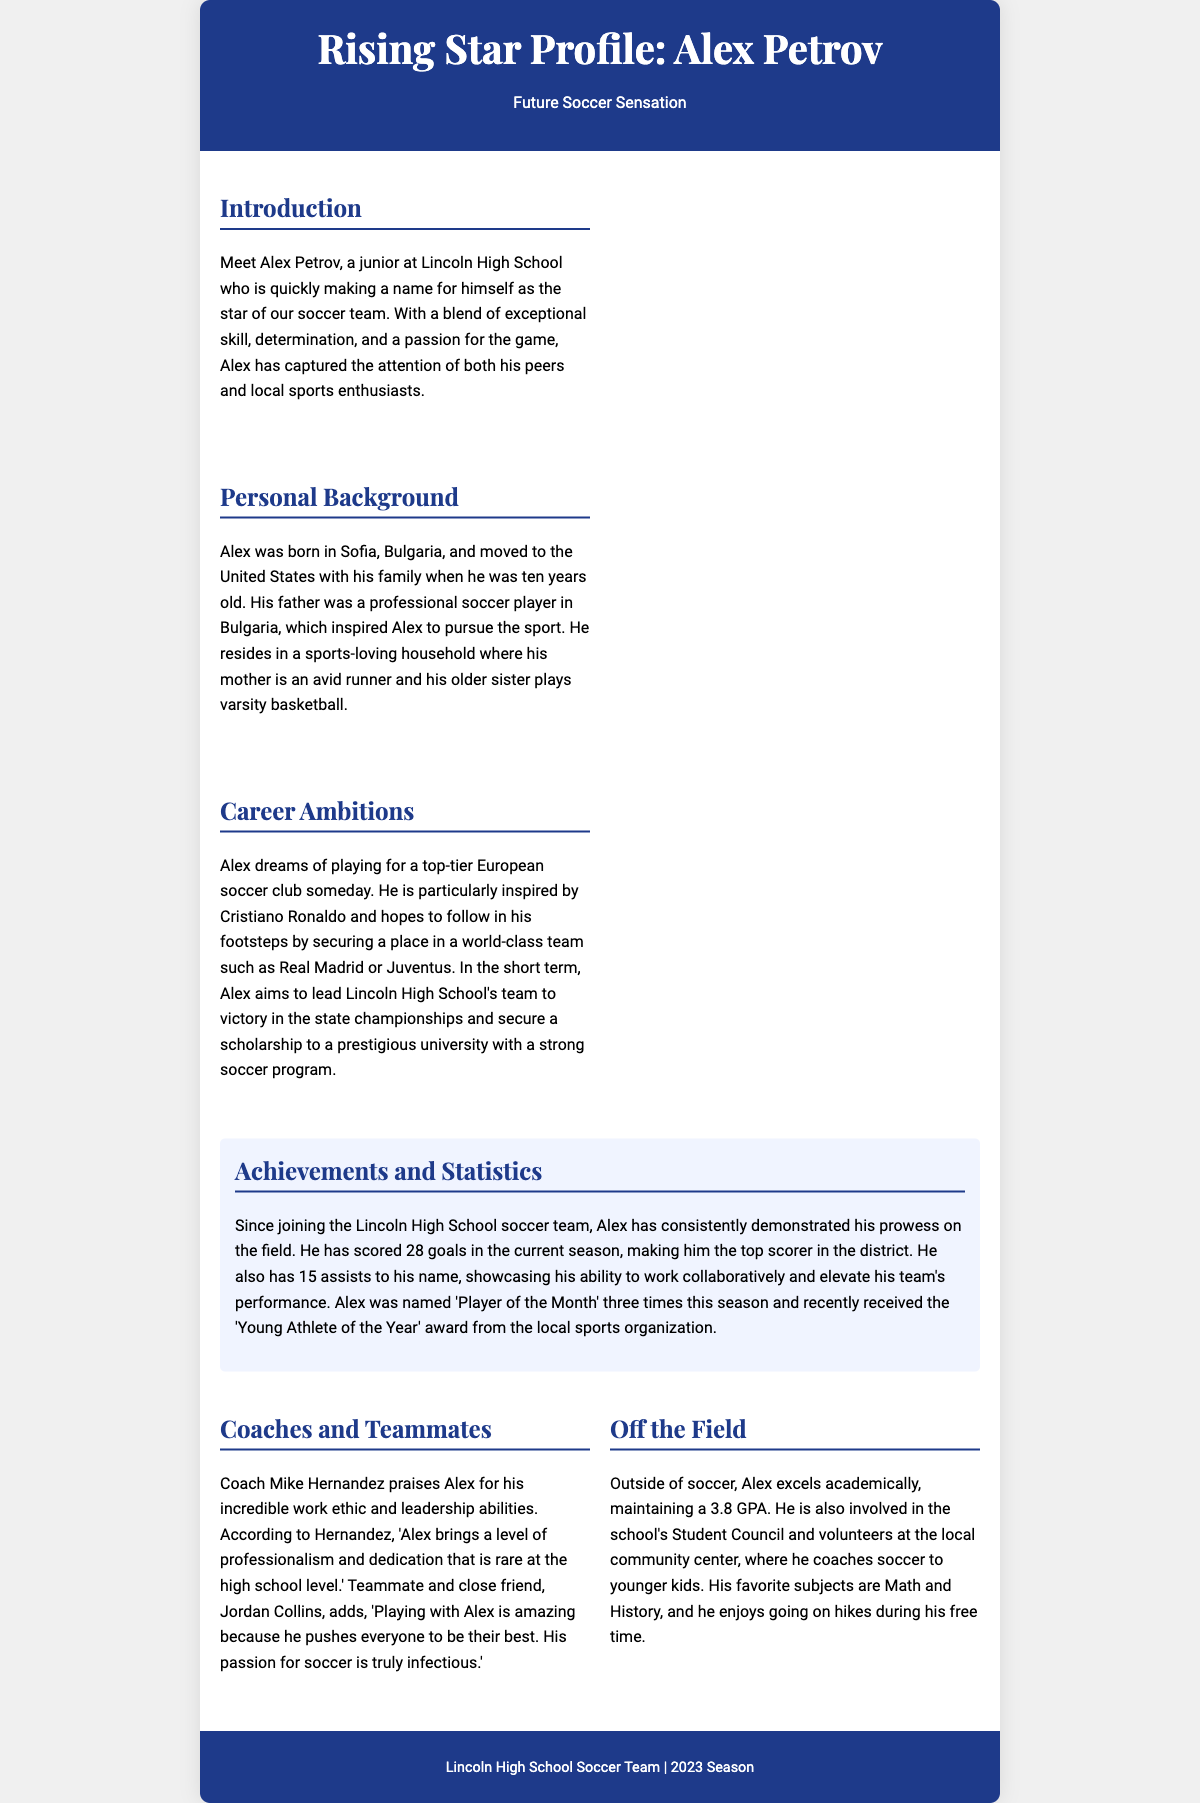What is Alex Petrov's GPA? The document states that Alex excels academically, maintaining a 3.8 GPA.
Answer: 3.8 Where was Alex Petrov born? The document mentions that Alex was born in Sofia, Bulgaria.
Answer: Sofia, Bulgaria How many goals has Alex scored this season? According to the achievements section, Alex has scored 28 goals in the current season.
Answer: 28 Who inspires Alex Petrov? The document notes that Alex is particularly inspired by Cristiano Ronaldo.
Answer: Cristiano Ronaldo What position does Alex aspire to play for in the future? The document states that Alex dreams of playing for a top-tier European soccer club someday.
Answer: Top-tier European soccer club Who is Alex's close friend and teammate? It is mentioned that Jordan Collins is a teammate and close friend of Alex.
Answer: Jordan Collins How many times was Alex named 'Player of the Month'? The achievements section indicates that Alex was named 'Player of the Month' three times this season.
Answer: Three times What does Coach Mike Hernandez say about Alex? The document quotes Coach Hernandez praising Alex's incredible work ethic and leadership abilities.
Answer: Incredible work ethic and leadership abilities In which extracurricular activity is Alex involved? The document states that Alex is involved in the school's Student Council.
Answer: Student Council 